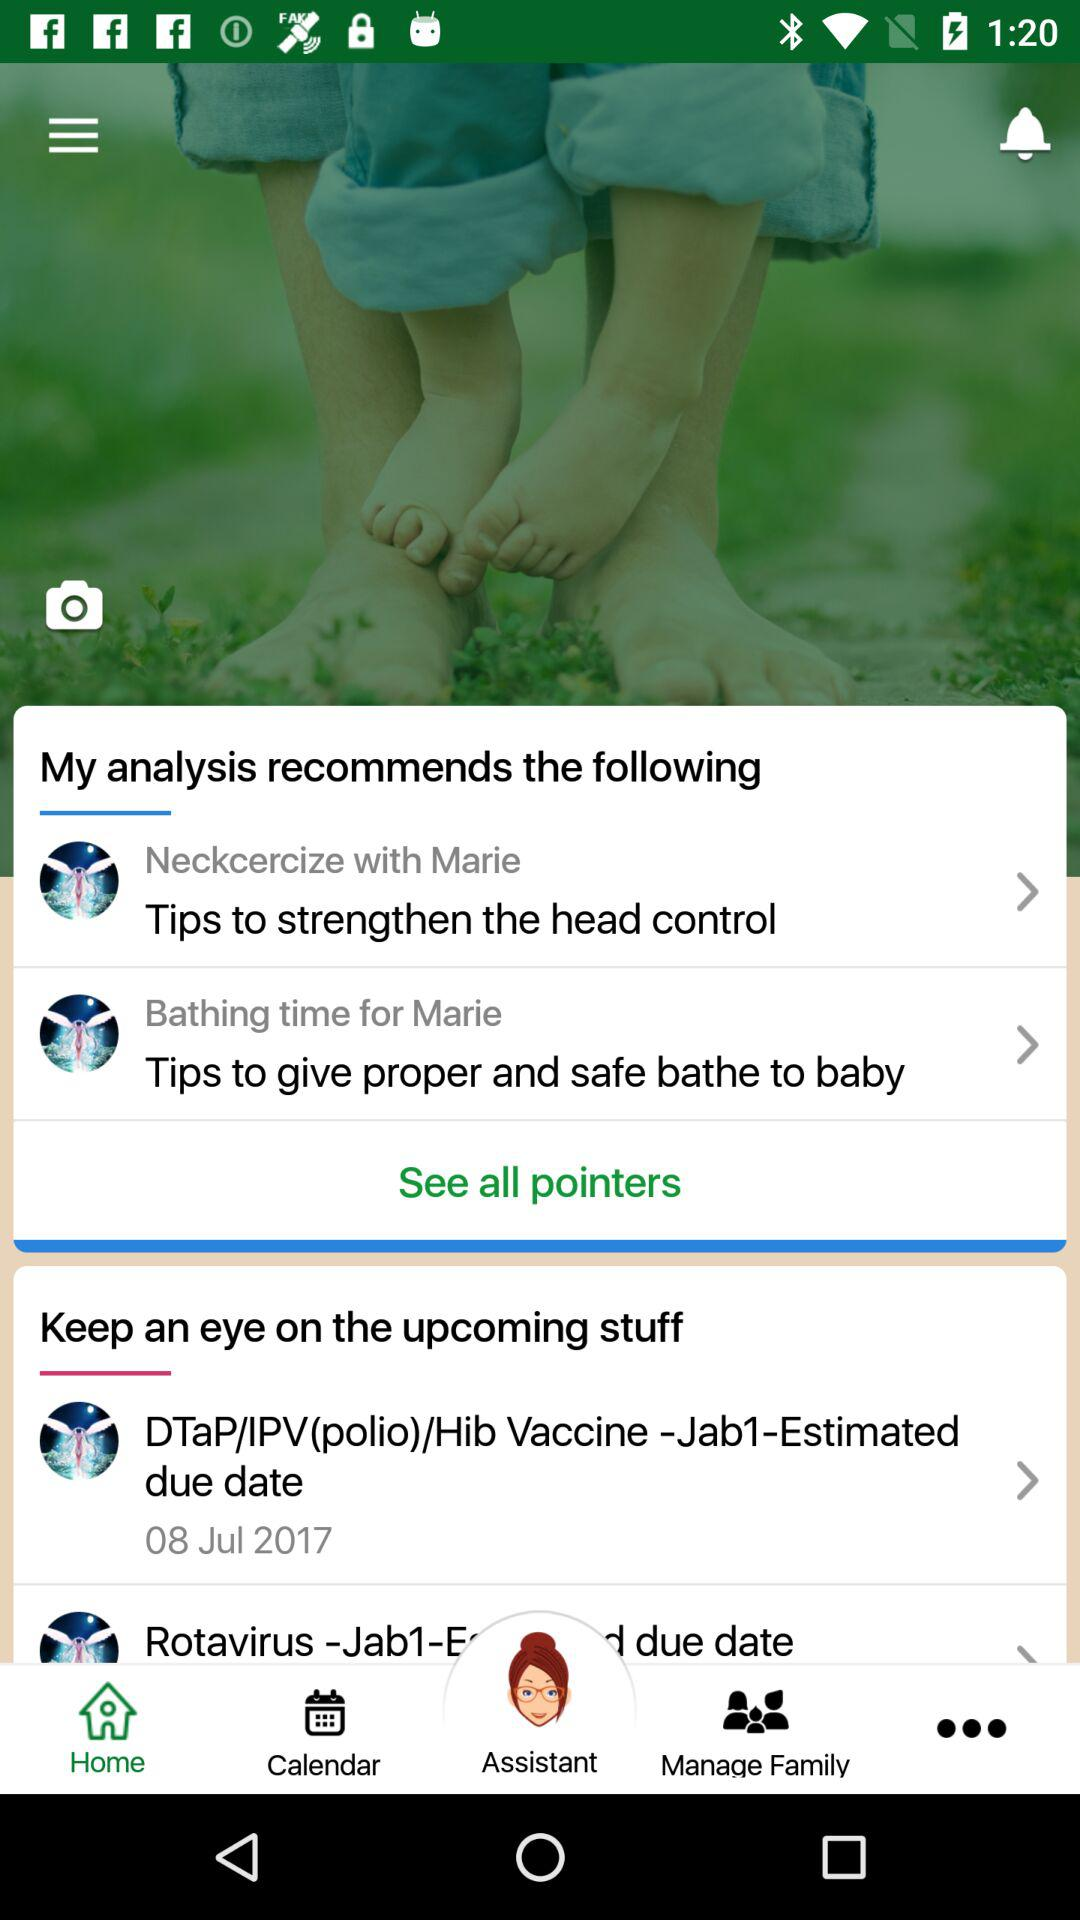What is the estimated due date of the Hib vaccine? The estimated due date is July 8, 2017. 